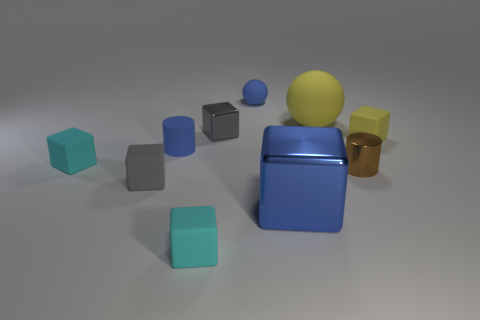There is a gray metallic object that is the same size as the yellow matte cube; what shape is it? cube 